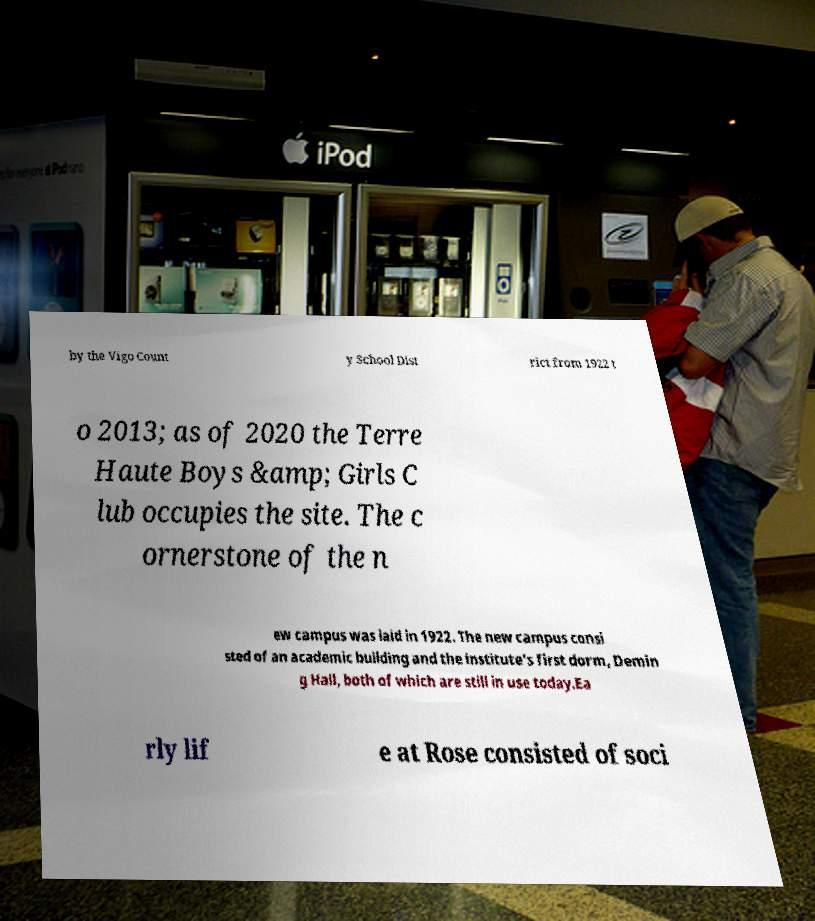Could you assist in decoding the text presented in this image and type it out clearly? by the Vigo Count y School Dist rict from 1922 t o 2013; as of 2020 the Terre Haute Boys &amp; Girls C lub occupies the site. The c ornerstone of the n ew campus was laid in 1922. The new campus consi sted of an academic building and the institute's first dorm, Demin g Hall, both of which are still in use today.Ea rly lif e at Rose consisted of soci 